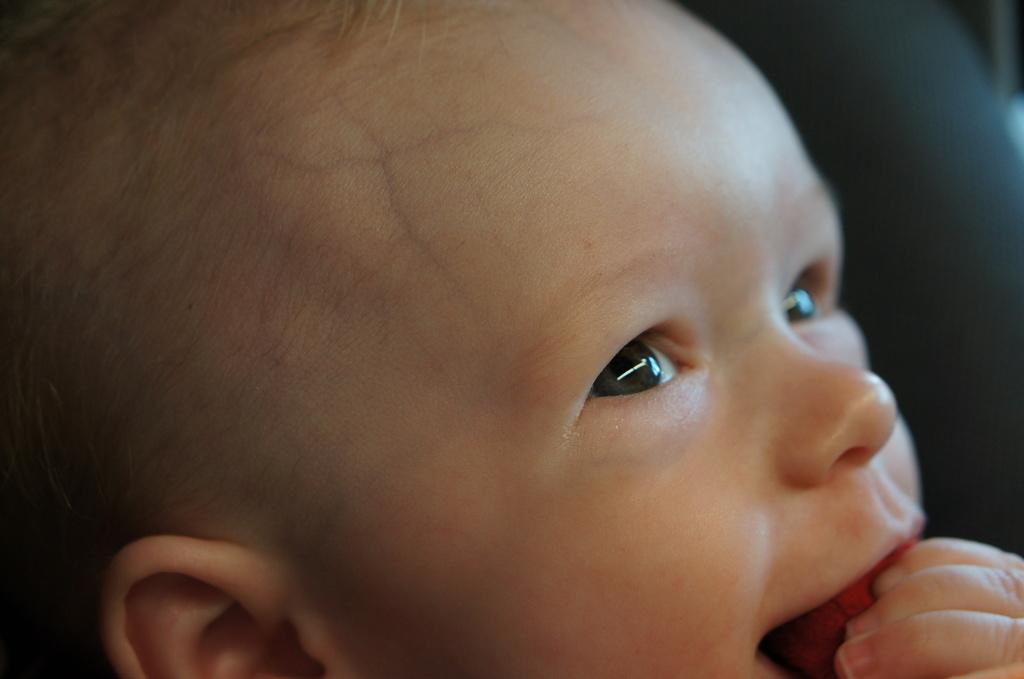What is the main subject of the image? The main subject of the image is a baby. What is the baby doing in the image? The baby has its fingers in its mouth. What type of operation is being performed on the baby in the image? There is no operation being performed on the baby in the image; the baby is simply putting its fingers in its mouth. What kind of cracker is the baby holding in the image? There is no cracker present in the image; the baby has its fingers in its mouth. 